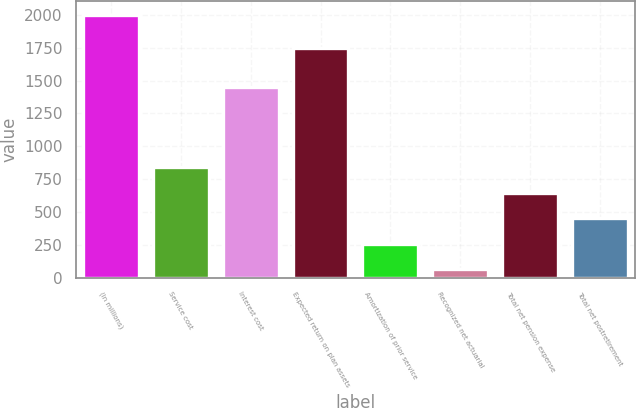Convert chart to OTSL. <chart><loc_0><loc_0><loc_500><loc_500><bar_chart><fcel>(In millions)<fcel>Service cost<fcel>Interest cost<fcel>Expected return on plan assets<fcel>Amortization of prior service<fcel>Recognized net actuarial<fcel>Total net pension expense<fcel>Total net postretirement<nl><fcel>2003<fcel>838.4<fcel>1453<fcel>1748<fcel>256.1<fcel>62<fcel>644.3<fcel>450.2<nl></chart> 